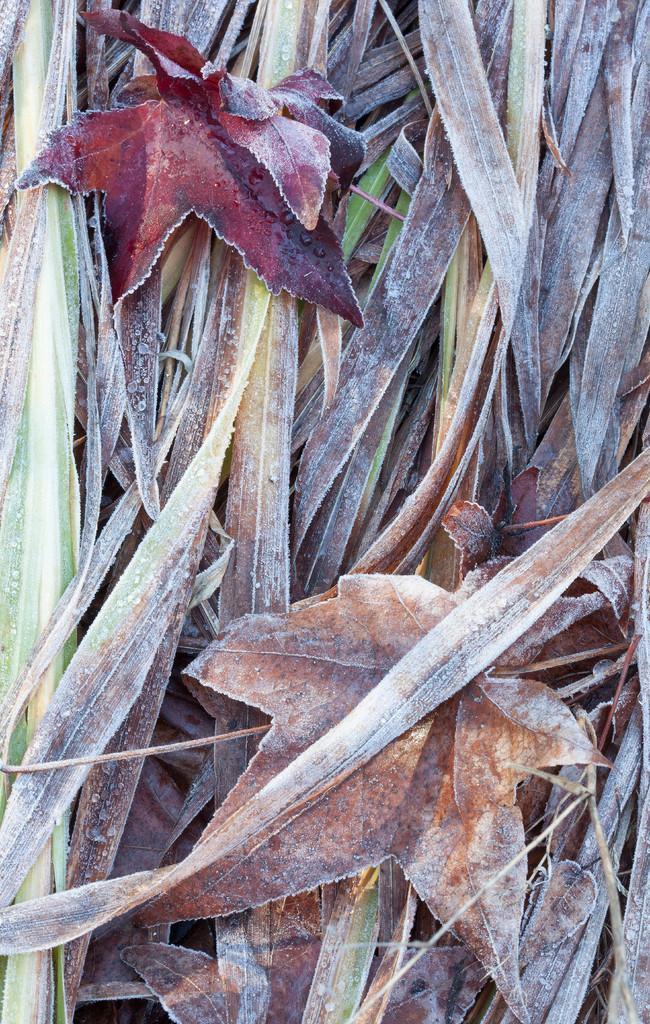Could you give a brief overview of what you see in this image? In this image we can see leaves. 